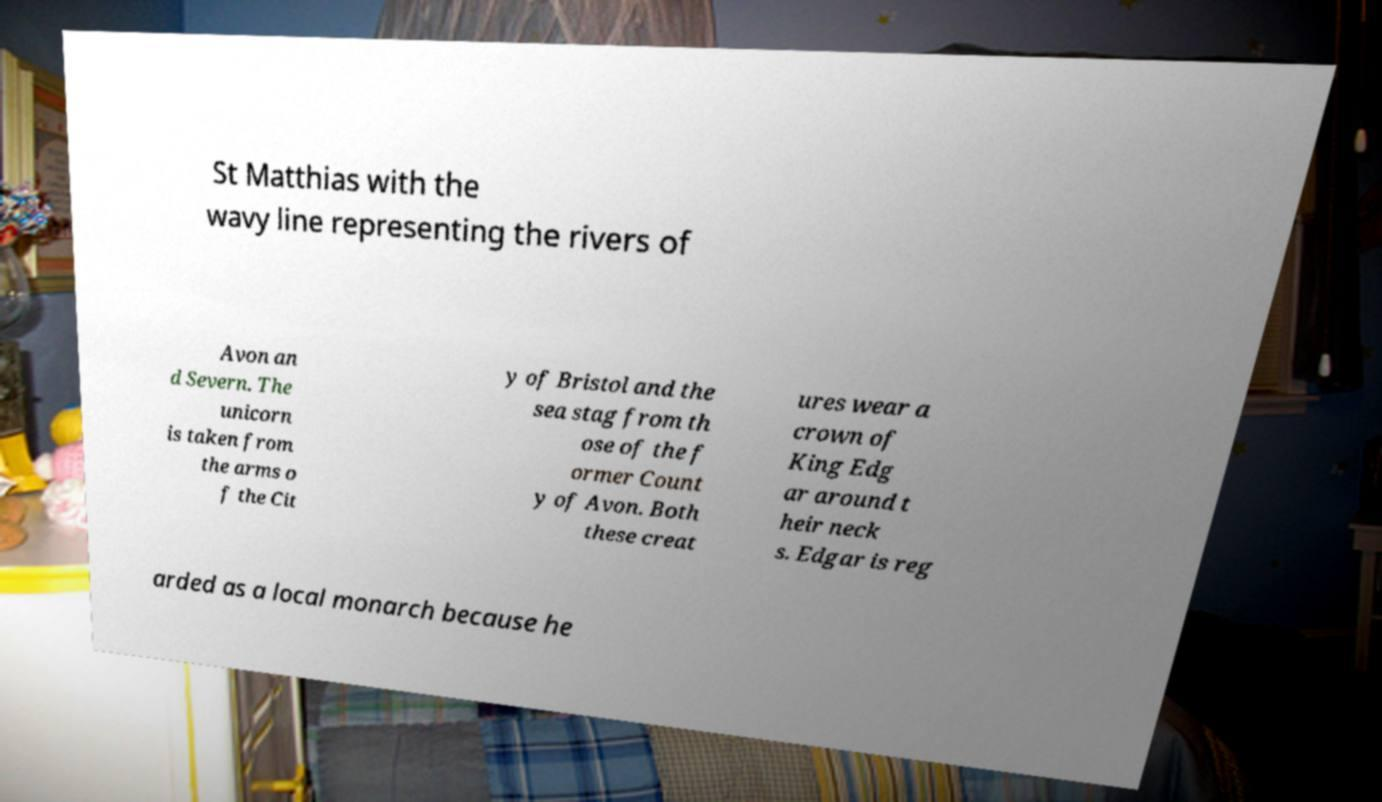Can you accurately transcribe the text from the provided image for me? St Matthias with the wavy line representing the rivers of Avon an d Severn. The unicorn is taken from the arms o f the Cit y of Bristol and the sea stag from th ose of the f ormer Count y of Avon. Both these creat ures wear a crown of King Edg ar around t heir neck s. Edgar is reg arded as a local monarch because he 